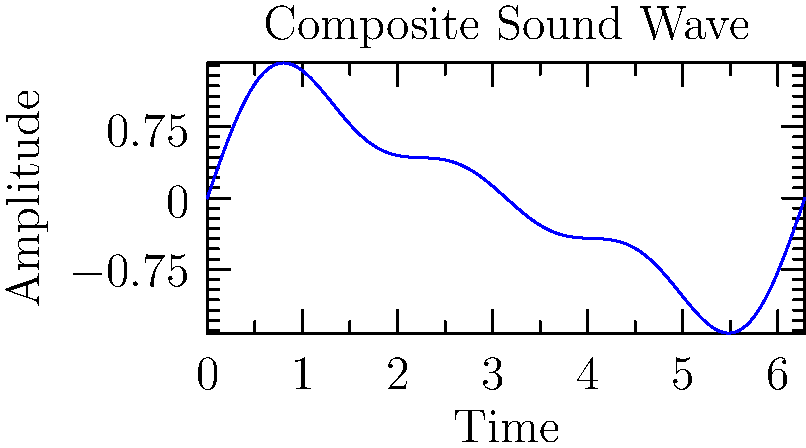Analyze the given composite sound wave. Which of the following frequency components are present in the waveform?

A) Fundamental frequency only
B) Fundamental and second harmonic
C) Fundamental, second, and third harmonics
D) Fundamental and third harmonic To analyze the frequency components of this composite sound wave, we need to follow these steps:

1. Observe the waveform: The graph shows a complex periodic wave that repeats over time.

2. Identify the fundamental frequency: This is the lowest frequency component and determines the overall period of the wave. In this case, it's represented by the $\sin(t)$ term.

3. Look for higher harmonics:
   a) The second harmonic would have twice the frequency of the fundamental, represented by $\sin(2t)$.
   b) The third harmonic would have three times the frequency of the fundamental, represented by $\sin(3t)$.

4. Analyze the wave shape:
   - The wave is not a pure sine wave, indicating the presence of harmonics.
   - There are visible smaller oscillations superimposed on the main wave, suggesting higher frequency components.

5. Mathematical representation: The wave can be described by the equation:

   $$y(t) = \sin(t) + 0.5\sin(2t) + 0.3\sin(3t)$$

   This equation confirms the presence of the fundamental frequency ($\sin(t)$), the second harmonic ($0.5\sin(2t)$), and the third harmonic ($0.3\sin(3t)$).

6. Conclusion: Based on this analysis, we can determine that the waveform contains the fundamental frequency, the second harmonic, and the third harmonic.
Answer: C) Fundamental, second, and third harmonics 